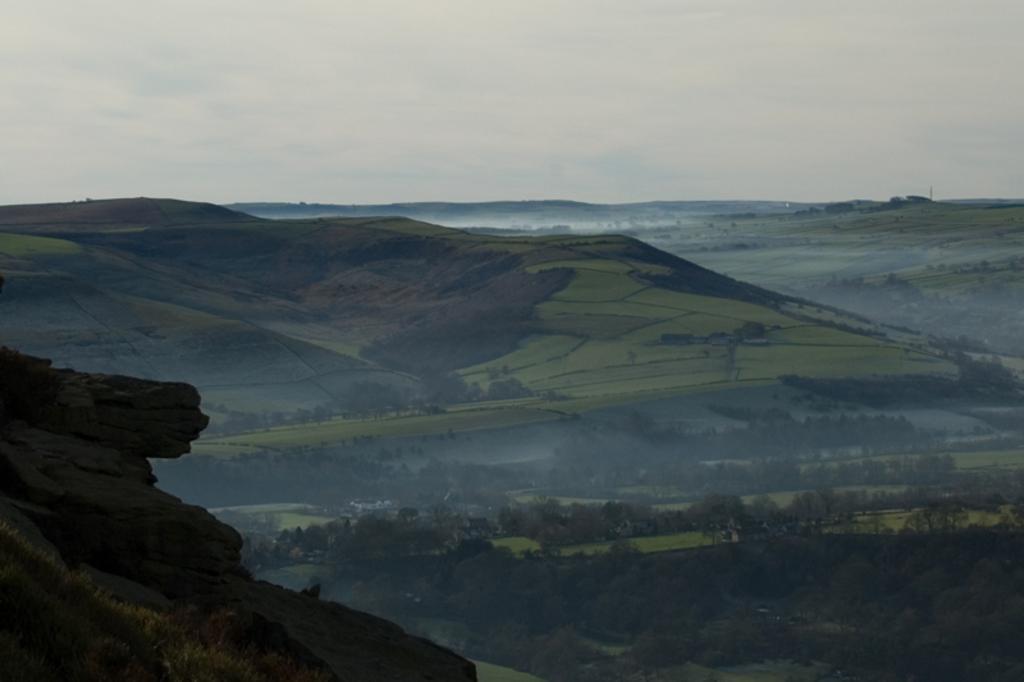Can you describe this image briefly? In this image I can see trees and grass in green color. Background I can see water, and sky in white color. 